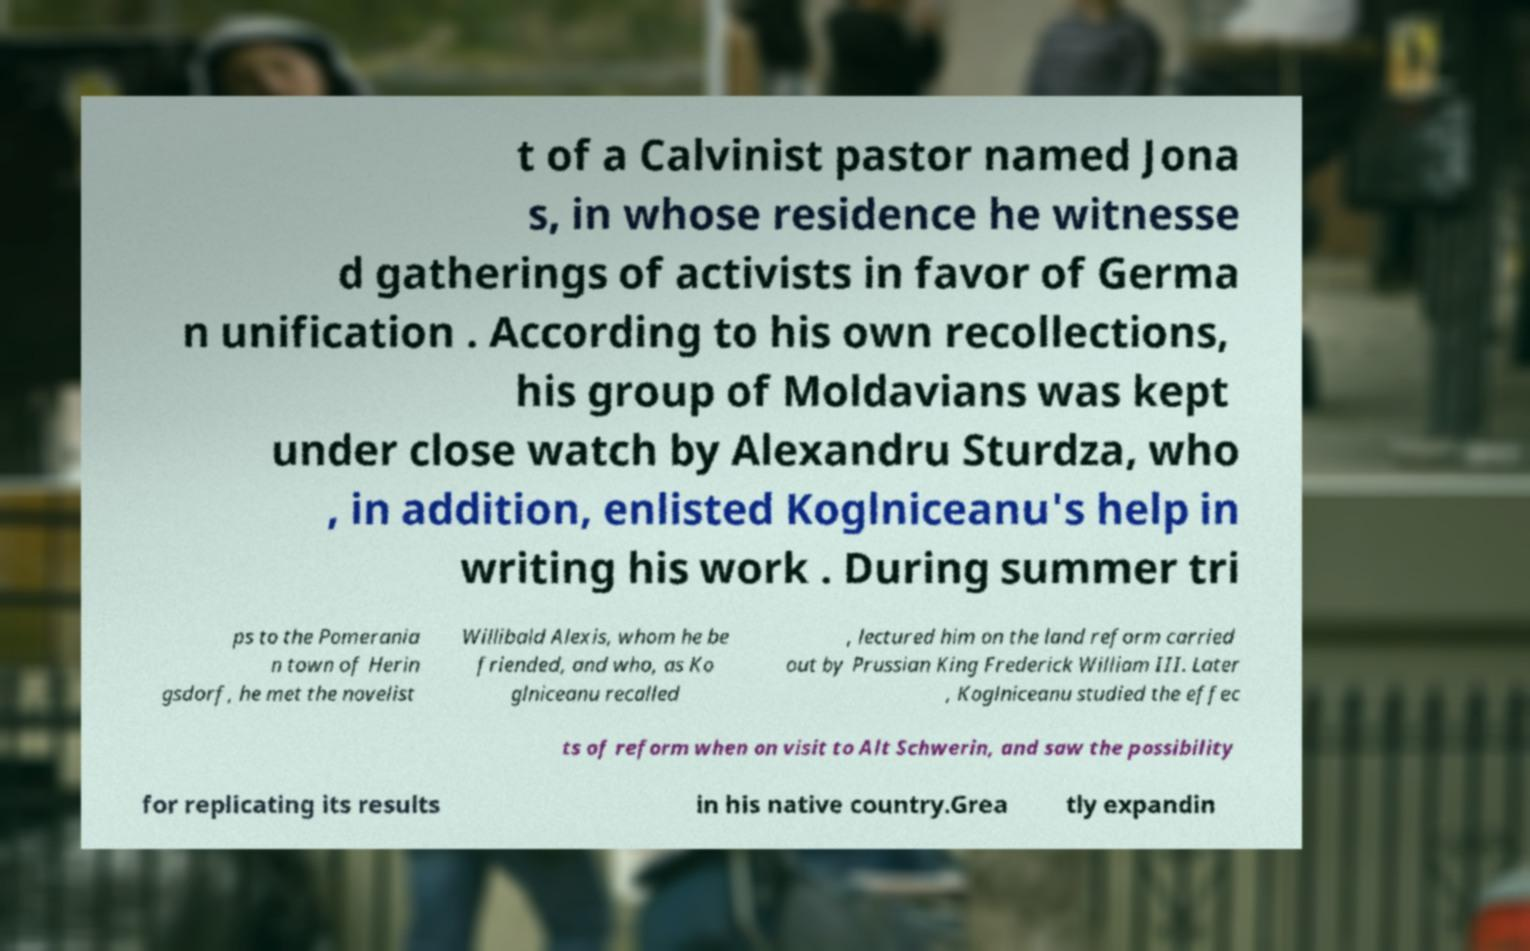Can you accurately transcribe the text from the provided image for me? t of a Calvinist pastor named Jona s, in whose residence he witnesse d gatherings of activists in favor of Germa n unification . According to his own recollections, his group of Moldavians was kept under close watch by Alexandru Sturdza, who , in addition, enlisted Koglniceanu's help in writing his work . During summer tri ps to the Pomerania n town of Herin gsdorf, he met the novelist Willibald Alexis, whom he be friended, and who, as Ko glniceanu recalled , lectured him on the land reform carried out by Prussian King Frederick William III. Later , Koglniceanu studied the effec ts of reform when on visit to Alt Schwerin, and saw the possibility for replicating its results in his native country.Grea tly expandin 